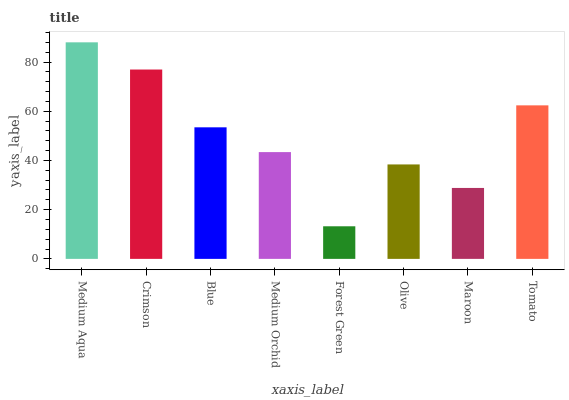Is Crimson the minimum?
Answer yes or no. No. Is Crimson the maximum?
Answer yes or no. No. Is Medium Aqua greater than Crimson?
Answer yes or no. Yes. Is Crimson less than Medium Aqua?
Answer yes or no. Yes. Is Crimson greater than Medium Aqua?
Answer yes or no. No. Is Medium Aqua less than Crimson?
Answer yes or no. No. Is Blue the high median?
Answer yes or no. Yes. Is Medium Orchid the low median?
Answer yes or no. Yes. Is Tomato the high median?
Answer yes or no. No. Is Olive the low median?
Answer yes or no. No. 